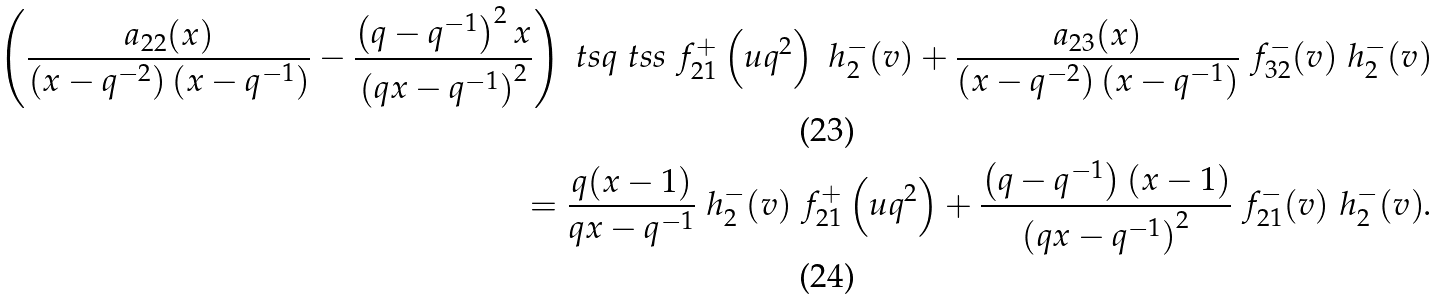Convert formula to latex. <formula><loc_0><loc_0><loc_500><loc_500>\left ( \frac { a _ { 2 2 } ( x ) } { \left ( x - q ^ { - 2 } \right ) \left ( x - q ^ { - 1 } \right ) } - \frac { \left ( q - q ^ { - 1 } \right ) ^ { 2 } x } { \left ( q x - q ^ { - 1 } \right ) ^ { 2 } } \right ) \ t s q \ t s s \ f _ { 2 1 } ^ { + } \left ( u q ^ { 2 } \right ) \ h _ { 2 } ^ { - } ( v ) + \frac { a _ { 2 3 } ( x ) } { \left ( x - q ^ { - 2 } \right ) \left ( x - q ^ { - 1 } \right ) } \ f _ { 3 2 } ^ { - } ( v ) \ h _ { 2 } ^ { - } ( v ) \\ = \frac { q ( x - 1 ) } { q x - q ^ { - 1 } } \ h ^ { - } _ { 2 } ( v ) \ f _ { 2 1 } ^ { + } \left ( u q ^ { 2 } \right ) + \frac { \left ( q - q ^ { - 1 } \right ) ( x - 1 ) } { \left ( q x - q ^ { - 1 } \right ) ^ { 2 } } \ f ^ { - } _ { 2 1 } ( v ) \ h ^ { - } _ { 2 } ( v ) .</formula> 